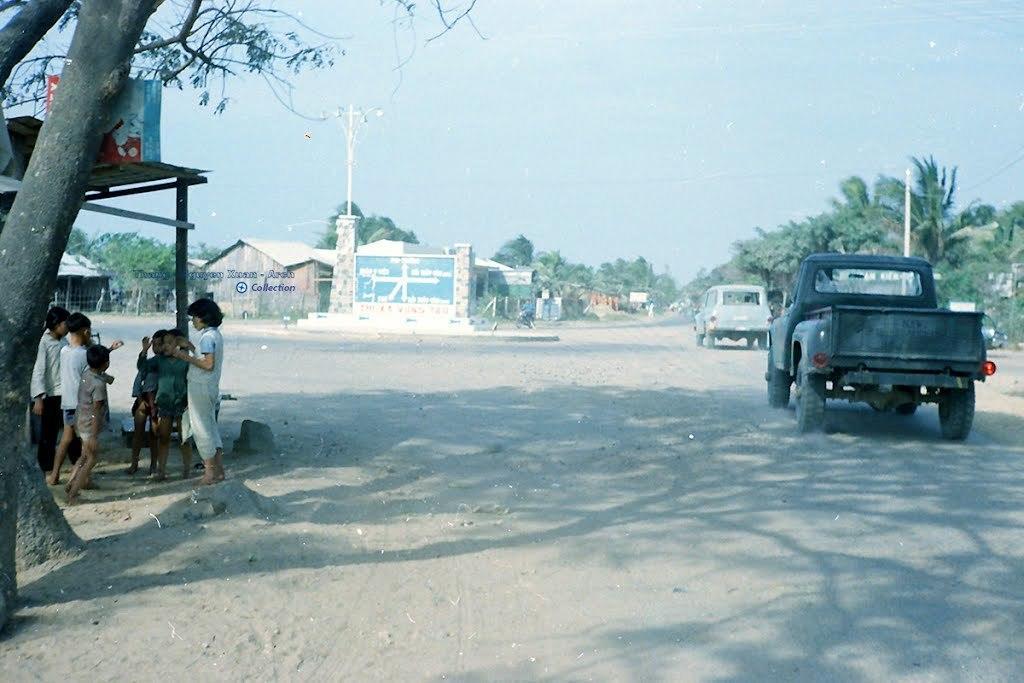How would you summarize this image in a sentence or two? In this image we can see some vehicles on the road. On the left side of the image there are some children under the tree. In front of the vehicles there are some buildings, trees, poles and the sky. On the image it is written Something. 